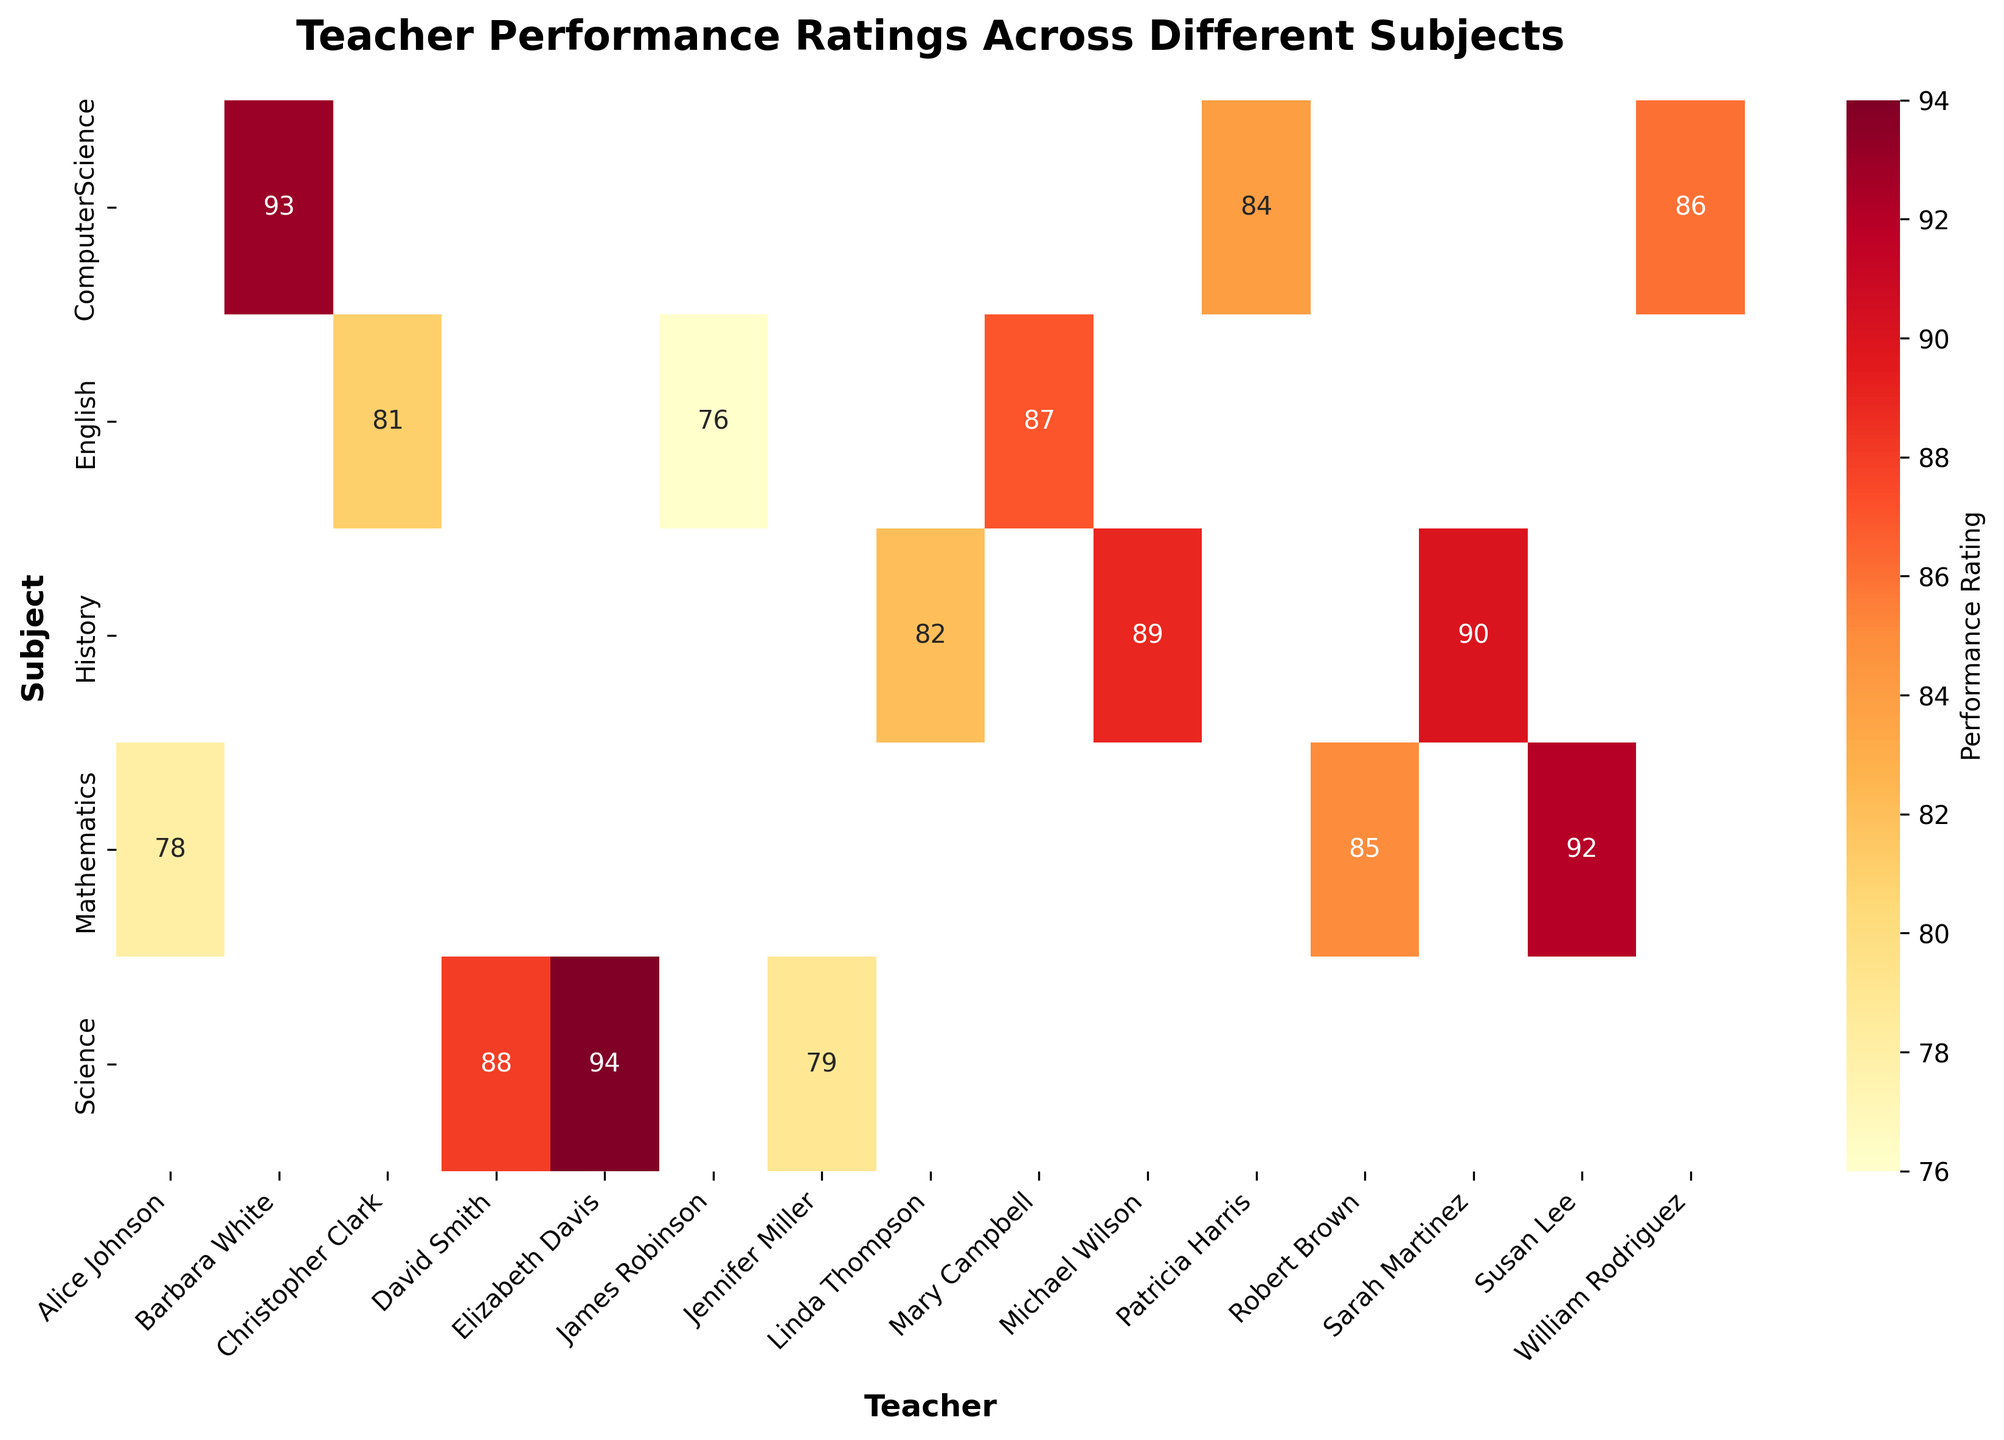What subject does Jennifer Miller teach, and what is her performance rating? We can find Jennifer Miller by looking at the teacher names on the x-axis and then check the corresponding subject on the y-axis. Her performance rating is the value at the intersection of her name and subject.
Answer: Science, 79 Which subject has the highest average performance rating across all teachers? To determine the subject with the highest average performance rating, we calculate the average rating for each subject. Mathematics: (78 + 85 + 92) / 3 = 85, Science: (88 + 79 + 94) / 3 = 87, English: (81 + 87 + 76) / 3 = 81.33, History: (82 + 89 + 90) / 3 = 87, Computer Science: (86 + 93 + 84) / 3 = 87.67. The highest average rating is for Computer Science.
Answer: Computer Science How does Patricia Harris’s performance rating compare to William Rodriguez's? We locate Patricia Harris and William Rodriguez on the x-axis under Computer Science and compare their ratings at their intersections. Patricia Harris has a rating of 84, and William Rodriguez has a rating of 86.
Answer: Patricia Harris's rating is lower than William Rodriguez's by 2 points Who is the highest-rated teacher for Mathematics? We look at the Mathematics row and identify the highest value, which corresponds to the teacher's name on the x-axis. The highest rating in Mathematics is 92 by Susan Lee.
Answer: Susan Lee with a rating of 92 What are the performance ratings for all English teachers? Locate the English row, and check all the values at the intersection with teacher names. Christopher Clark: 81, Mary Campbell: 87, James Robinson: 76.
Answer: 81, 87, 76 Which subject has the most consistent performance ratings among its teachers? We determine consistency by looking at the range (difference between the maximum and minimum values) of ratings in each subject. Mathematics: 92 - 78 = 14, Science: 94 - 79 = 15, English: 87 - 76 = 11, History: 90 - 82 = 8, Computer Science: 93 - 84 = 9. History has the smallest range and thus has the most consistent ratings.
Answer: History What is the difference between the highest and lowest performance ratings in Science? We locate the Science row and identify the highest and lowest values. The highest rating is 94 (Elizabeth Davis), and the lowest is 79 (Jennifer Miller). Their difference is 94 - 79.
Answer: 15 In which subject does Michael Wilson teach, and what is his performance rating? Find Michael Wilson by looking at the teacher names on the x-axis, then check the corresponding subject on the y-axis. His rating is at the intersection. Michael Wilson teaches History with a rating of 89.
Answer: History, 89 What is the overall highest performance rating, and which teacher-subject pair does it belong to? We scan the heatmap for the highest numerical value. The maximum rating is 94, which corresponds to Elizabeth Davis under Science and Barbara White under Computer Science.
Answer: 94, Elizabeth Davis (Science) and Barbara White (Computer Science) 